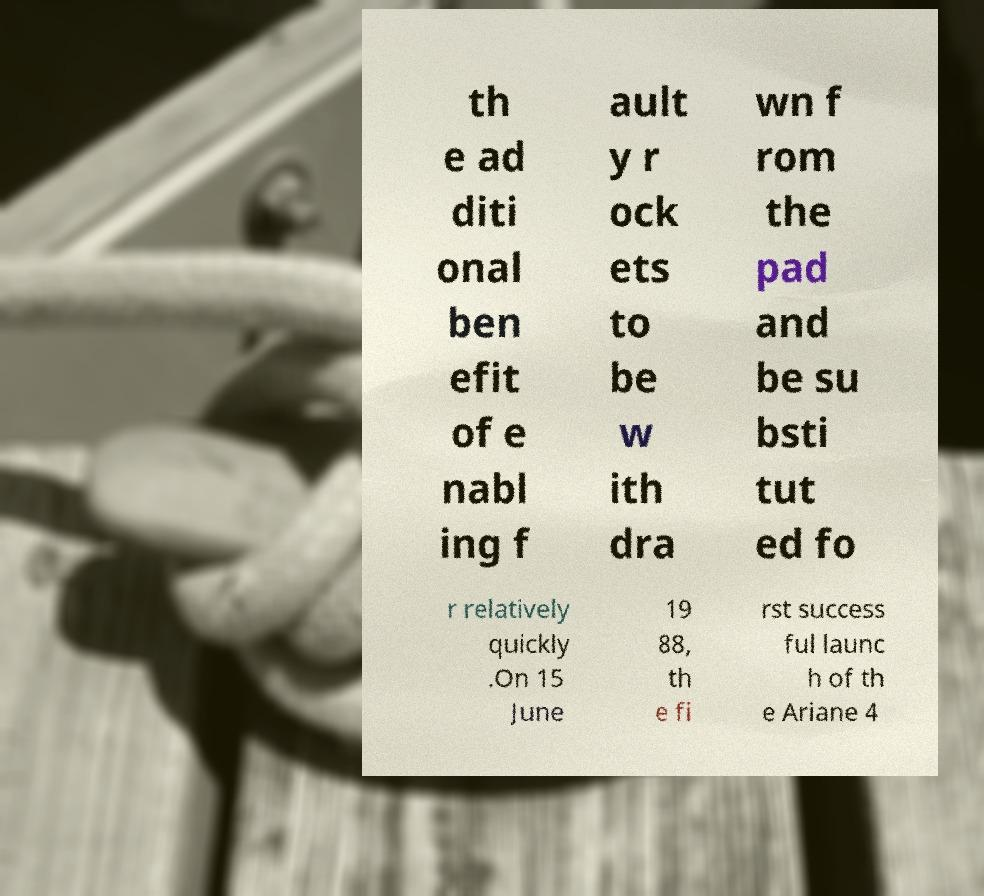What messages or text are displayed in this image? I need them in a readable, typed format. th e ad diti onal ben efit of e nabl ing f ault y r ock ets to be w ith dra wn f rom the pad and be su bsti tut ed fo r relatively quickly .On 15 June 19 88, th e fi rst success ful launc h of th e Ariane 4 